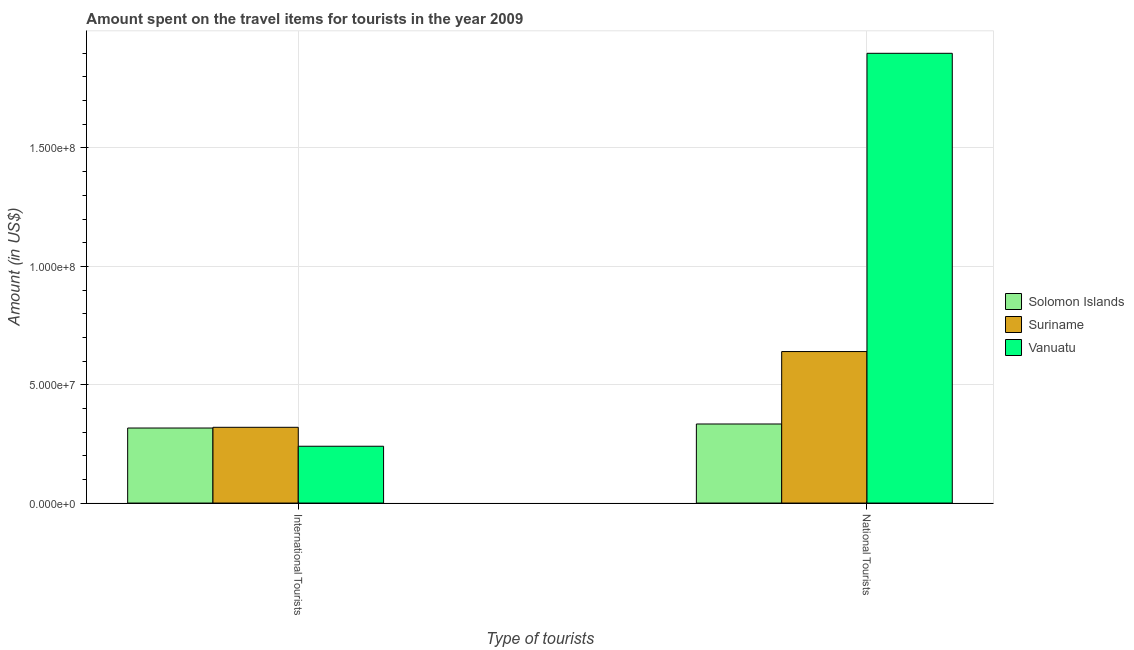How many bars are there on the 1st tick from the left?
Give a very brief answer. 3. How many bars are there on the 2nd tick from the right?
Provide a short and direct response. 3. What is the label of the 1st group of bars from the left?
Give a very brief answer. International Tourists. What is the amount spent on travel items of international tourists in Vanuatu?
Offer a terse response. 2.40e+07. Across all countries, what is the maximum amount spent on travel items of international tourists?
Make the answer very short. 3.20e+07. Across all countries, what is the minimum amount spent on travel items of national tourists?
Give a very brief answer. 3.34e+07. In which country was the amount spent on travel items of international tourists maximum?
Provide a short and direct response. Suriname. In which country was the amount spent on travel items of national tourists minimum?
Offer a very short reply. Solomon Islands. What is the total amount spent on travel items of national tourists in the graph?
Keep it short and to the point. 2.87e+08. What is the difference between the amount spent on travel items of international tourists in Suriname and that in Vanuatu?
Make the answer very short. 8.00e+06. What is the difference between the amount spent on travel items of international tourists in Suriname and the amount spent on travel items of national tourists in Solomon Islands?
Give a very brief answer. -1.40e+06. What is the average amount spent on travel items of international tourists per country?
Ensure brevity in your answer.  2.92e+07. What is the difference between the amount spent on travel items of international tourists and amount spent on travel items of national tourists in Vanuatu?
Your answer should be very brief. -1.66e+08. In how many countries, is the amount spent on travel items of international tourists greater than 60000000 US$?
Make the answer very short. 0. What is the ratio of the amount spent on travel items of international tourists in Solomon Islands to that in Suriname?
Your answer should be compact. 0.99. Is the amount spent on travel items of national tourists in Vanuatu less than that in Solomon Islands?
Ensure brevity in your answer.  No. In how many countries, is the amount spent on travel items of national tourists greater than the average amount spent on travel items of national tourists taken over all countries?
Your answer should be compact. 1. What does the 3rd bar from the left in International Tourists represents?
Provide a short and direct response. Vanuatu. What does the 2nd bar from the right in National Tourists represents?
Your answer should be very brief. Suriname. How many bars are there?
Provide a short and direct response. 6. Are all the bars in the graph horizontal?
Provide a short and direct response. No. How many countries are there in the graph?
Keep it short and to the point. 3. What is the difference between two consecutive major ticks on the Y-axis?
Provide a short and direct response. 5.00e+07. Are the values on the major ticks of Y-axis written in scientific E-notation?
Your response must be concise. Yes. How many legend labels are there?
Your response must be concise. 3. How are the legend labels stacked?
Ensure brevity in your answer.  Vertical. What is the title of the graph?
Your answer should be very brief. Amount spent on the travel items for tourists in the year 2009. What is the label or title of the X-axis?
Make the answer very short. Type of tourists. What is the label or title of the Y-axis?
Keep it short and to the point. Amount (in US$). What is the Amount (in US$) of Solomon Islands in International Tourists?
Make the answer very short. 3.17e+07. What is the Amount (in US$) of Suriname in International Tourists?
Give a very brief answer. 3.20e+07. What is the Amount (in US$) in Vanuatu in International Tourists?
Your response must be concise. 2.40e+07. What is the Amount (in US$) in Solomon Islands in National Tourists?
Offer a terse response. 3.34e+07. What is the Amount (in US$) in Suriname in National Tourists?
Give a very brief answer. 6.40e+07. What is the Amount (in US$) in Vanuatu in National Tourists?
Your answer should be compact. 1.90e+08. Across all Type of tourists, what is the maximum Amount (in US$) in Solomon Islands?
Provide a short and direct response. 3.34e+07. Across all Type of tourists, what is the maximum Amount (in US$) in Suriname?
Your answer should be very brief. 6.40e+07. Across all Type of tourists, what is the maximum Amount (in US$) of Vanuatu?
Provide a short and direct response. 1.90e+08. Across all Type of tourists, what is the minimum Amount (in US$) in Solomon Islands?
Make the answer very short. 3.17e+07. Across all Type of tourists, what is the minimum Amount (in US$) of Suriname?
Offer a very short reply. 3.20e+07. Across all Type of tourists, what is the minimum Amount (in US$) in Vanuatu?
Make the answer very short. 2.40e+07. What is the total Amount (in US$) of Solomon Islands in the graph?
Give a very brief answer. 6.51e+07. What is the total Amount (in US$) in Suriname in the graph?
Provide a short and direct response. 9.60e+07. What is the total Amount (in US$) of Vanuatu in the graph?
Your answer should be very brief. 2.14e+08. What is the difference between the Amount (in US$) of Solomon Islands in International Tourists and that in National Tourists?
Ensure brevity in your answer.  -1.70e+06. What is the difference between the Amount (in US$) in Suriname in International Tourists and that in National Tourists?
Ensure brevity in your answer.  -3.20e+07. What is the difference between the Amount (in US$) in Vanuatu in International Tourists and that in National Tourists?
Make the answer very short. -1.66e+08. What is the difference between the Amount (in US$) in Solomon Islands in International Tourists and the Amount (in US$) in Suriname in National Tourists?
Offer a terse response. -3.23e+07. What is the difference between the Amount (in US$) in Solomon Islands in International Tourists and the Amount (in US$) in Vanuatu in National Tourists?
Offer a very short reply. -1.58e+08. What is the difference between the Amount (in US$) of Suriname in International Tourists and the Amount (in US$) of Vanuatu in National Tourists?
Offer a very short reply. -1.58e+08. What is the average Amount (in US$) in Solomon Islands per Type of tourists?
Your answer should be compact. 3.26e+07. What is the average Amount (in US$) in Suriname per Type of tourists?
Offer a terse response. 4.80e+07. What is the average Amount (in US$) of Vanuatu per Type of tourists?
Your response must be concise. 1.07e+08. What is the difference between the Amount (in US$) of Solomon Islands and Amount (in US$) of Vanuatu in International Tourists?
Your answer should be very brief. 7.70e+06. What is the difference between the Amount (in US$) in Solomon Islands and Amount (in US$) in Suriname in National Tourists?
Offer a terse response. -3.06e+07. What is the difference between the Amount (in US$) in Solomon Islands and Amount (in US$) in Vanuatu in National Tourists?
Ensure brevity in your answer.  -1.57e+08. What is the difference between the Amount (in US$) of Suriname and Amount (in US$) of Vanuatu in National Tourists?
Offer a terse response. -1.26e+08. What is the ratio of the Amount (in US$) in Solomon Islands in International Tourists to that in National Tourists?
Keep it short and to the point. 0.95. What is the ratio of the Amount (in US$) in Suriname in International Tourists to that in National Tourists?
Provide a short and direct response. 0.5. What is the ratio of the Amount (in US$) of Vanuatu in International Tourists to that in National Tourists?
Keep it short and to the point. 0.13. What is the difference between the highest and the second highest Amount (in US$) of Solomon Islands?
Give a very brief answer. 1.70e+06. What is the difference between the highest and the second highest Amount (in US$) of Suriname?
Keep it short and to the point. 3.20e+07. What is the difference between the highest and the second highest Amount (in US$) of Vanuatu?
Make the answer very short. 1.66e+08. What is the difference between the highest and the lowest Amount (in US$) of Solomon Islands?
Offer a terse response. 1.70e+06. What is the difference between the highest and the lowest Amount (in US$) of Suriname?
Your answer should be compact. 3.20e+07. What is the difference between the highest and the lowest Amount (in US$) of Vanuatu?
Offer a terse response. 1.66e+08. 